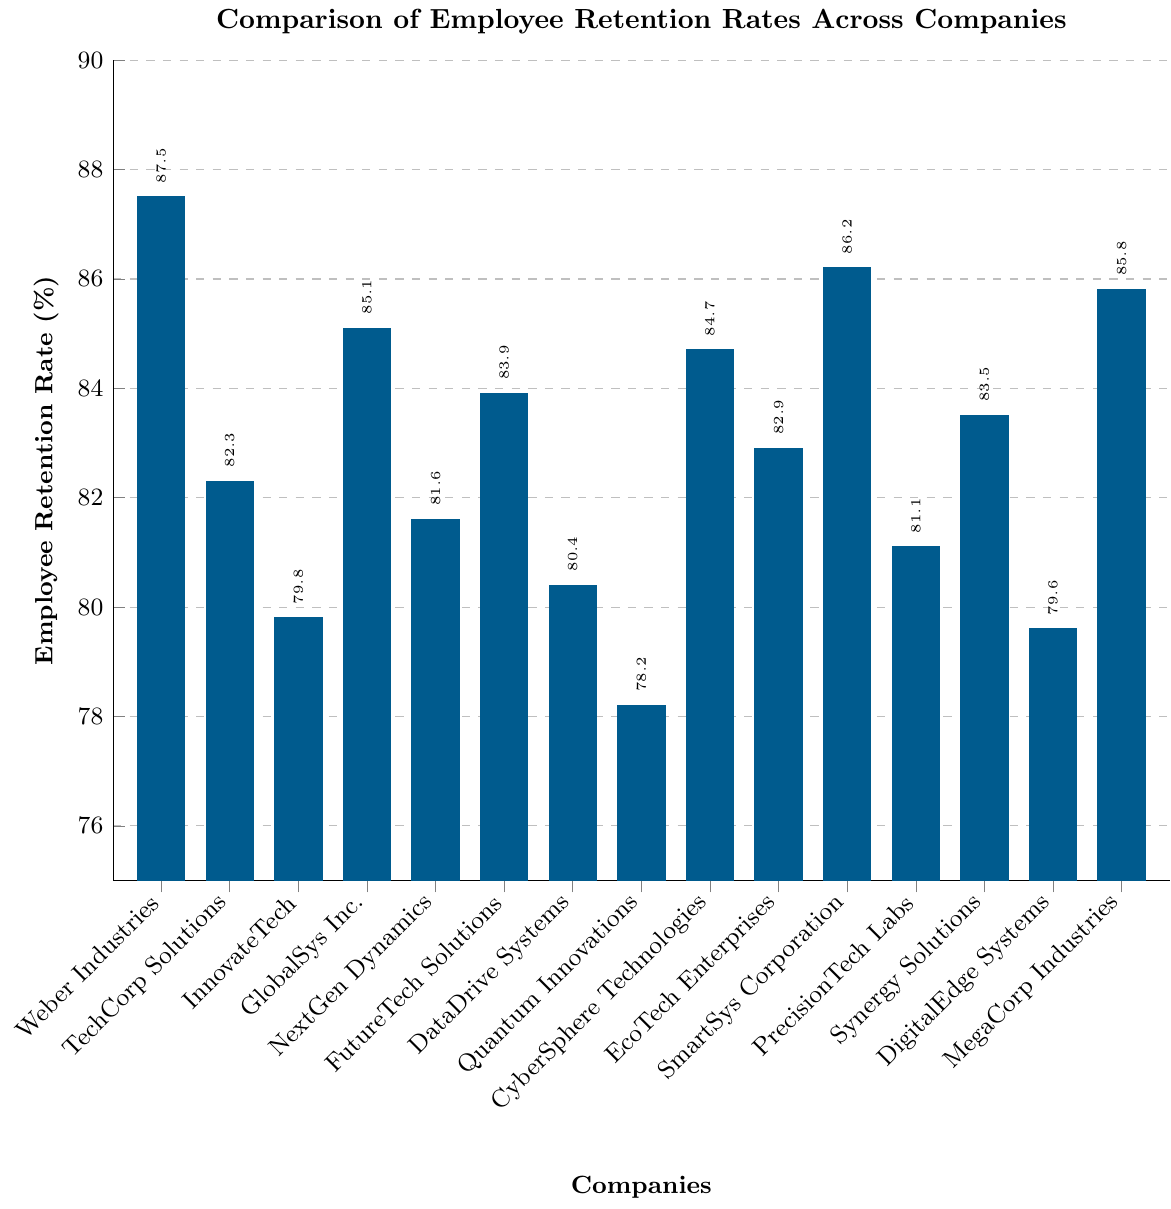What's the highest employee retention rate shown in the chart? The company with the highest bar visually represents the highest retention rate. "Weber Industries" has the tallest bar at 87.5%.
Answer: 87.5% Which company has the lowest employee retention rate? The shortest bar in the chart represents the company with the lowest retention rate. "Quantum Innovations" has the shortest bar at 78.2%.
Answer: Quantum Innovations Compare the employee retention rate of "Weber Industries" and "PrecisionTech Labs." Which company has a higher retention rate? By examining the chart, "Weber Industries" has a retention rate of 87.5% and "PrecisionTech Labs" has a retention rate of 81.1%.
Answer: Weber Industries What is the sum of retention rates for "TechCorp Solutions" and "CyberSphere Technologies"? Identify the retention rates for both companies: "TechCorp Solutions" (82.3%) and "CyberSphere Technologies" (84.7%). The sum is 82.3 + 84.7.
Answer: 167.0 Which two companies have retention rates closest to each other? By visually inspecting the bars, "EcoTech Enterprises" (82.9%) and "TechCorp Solutions" (82.3%) have very close retention rates.
Answer: TechCorp Solutions and EcoTech Enterprises Is the retention rate of "MegaCorp Industries" greater than the sector's median retention rate? First, list the retention rates and determine the median, which is 82.9%. "MegaCorp Industries" has a retention rate of 85.8%, which is higher than the median.
Answer: Yes Calculate the average retention rate of the companies listed in the chart. Sum all the retention rates and divide by the number of companies (15). (87.5 + 82.3 + 79.8 + 85.1 + 81.6 + 83.9 + 80.4 + 78.2 + 84.7 + 82.9 + 86.2 + 81.1 + 83.5 + 79.6 + 85.8) / 15 = 82.9%.
Answer: 82.9% Between "FutureTech Solutions" and "InnovateTech," which company has the lower employee retention rate? By examining the chart, "FutureTech Solutions" has a retention rate of 83.9% and "InnovateTech" has a retention rate of 79.8%.
Answer: InnovateTech Compare the retention rates of "GlobalSys Inc." and "SmartSys Corporation." By how much does one exceed the other? The retention rate for "GlobalSys Inc." is 85.1%, and for "SmartSys Corporation," it is 86.2%. The difference is 86.2 - 85.1 = 1.1%.
Answer: 1.1% Which company has a retention rate of exactly 79.6%? By examining the chart, "DigitalEdge Systems" has a retention rate of 79.6%.
Answer: DigitalEdge Systems 